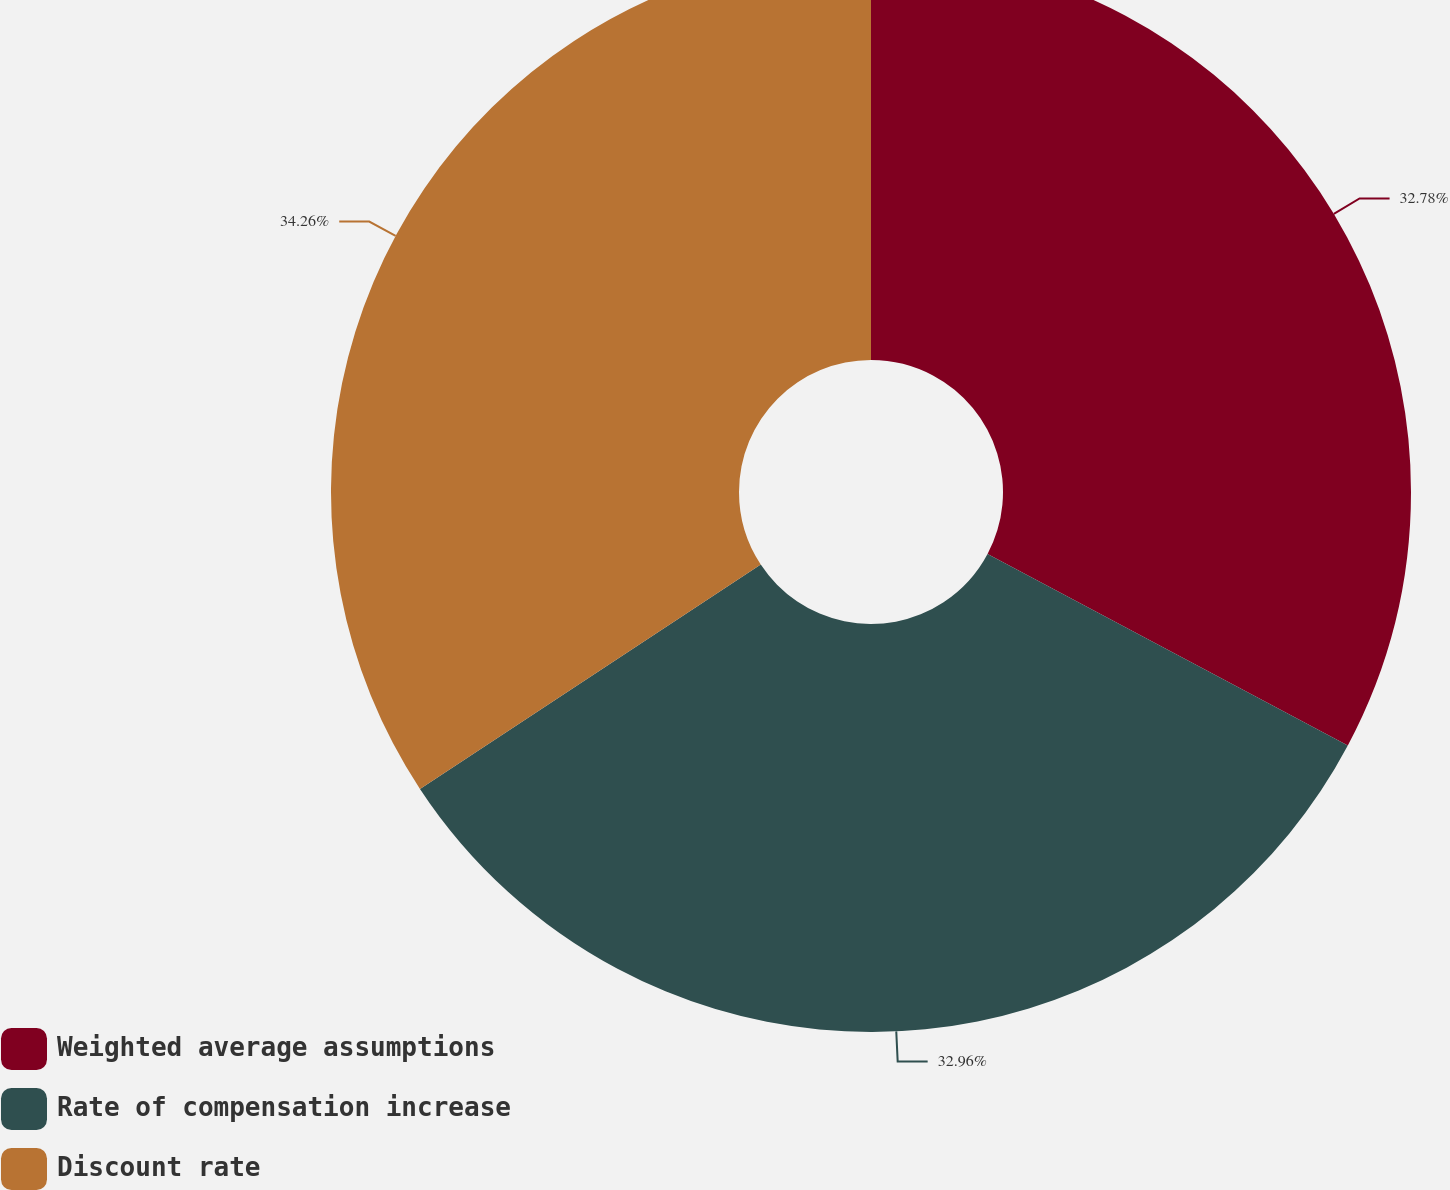Convert chart. <chart><loc_0><loc_0><loc_500><loc_500><pie_chart><fcel>Weighted average assumptions<fcel>Rate of compensation increase<fcel>Discount rate<nl><fcel>32.78%<fcel>32.96%<fcel>34.27%<nl></chart> 